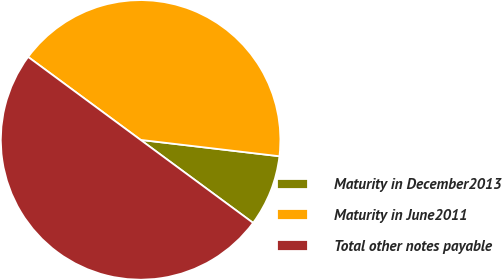Convert chart. <chart><loc_0><loc_0><loc_500><loc_500><pie_chart><fcel>Maturity in December2013<fcel>Maturity in June2011<fcel>Total other notes payable<nl><fcel>8.25%<fcel>41.75%<fcel>50.0%<nl></chart> 